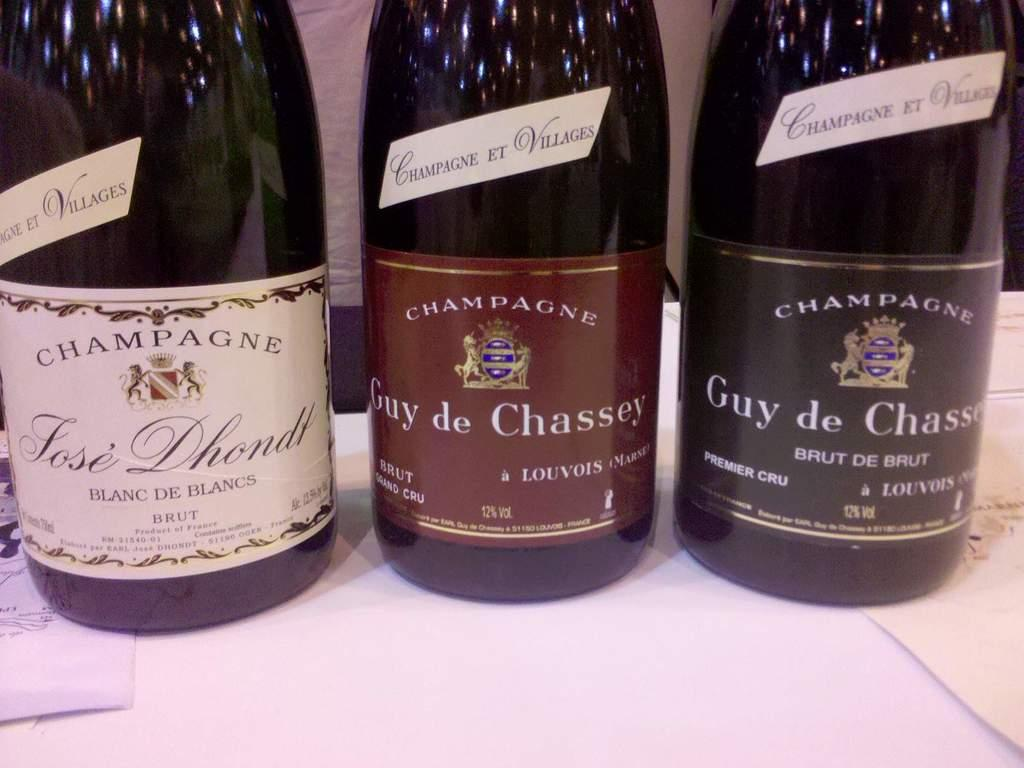<image>
Share a concise interpretation of the image provided. Three bottles of Champagne on a white surface 